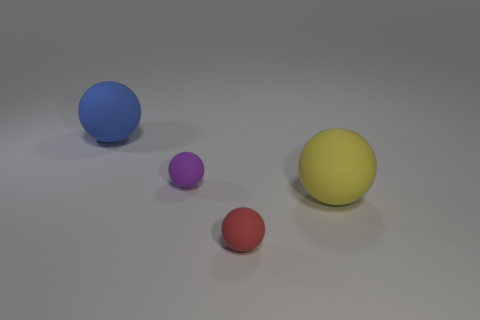How many objects are either tiny red spheres or matte cylinders?
Your answer should be very brief. 1. There is a big thing that is to the right of the small red object; does it have the same shape as the large object behind the tiny purple rubber object?
Keep it short and to the point. Yes. The large matte thing that is left of the small purple object has what shape?
Offer a very short reply. Sphere. Are there the same number of tiny spheres behind the large blue rubber thing and large blue balls that are in front of the big yellow matte thing?
Ensure brevity in your answer.  Yes. What number of things are large yellow cylinders or matte things that are in front of the purple rubber object?
Offer a terse response. 2. There is a object that is behind the yellow sphere and right of the blue matte thing; what shape is it?
Your answer should be compact. Sphere. Do the small ball that is on the left side of the small red rubber object and the red ball have the same material?
Your response must be concise. Yes. What size is the purple sphere that is to the right of the large blue sphere?
Give a very brief answer. Small. There is a small rubber ball that is behind the large yellow rubber thing; is there a big thing that is right of it?
Offer a very short reply. Yes. What color is the rubber object that is both left of the large yellow rubber ball and in front of the purple rubber thing?
Your response must be concise. Red. 